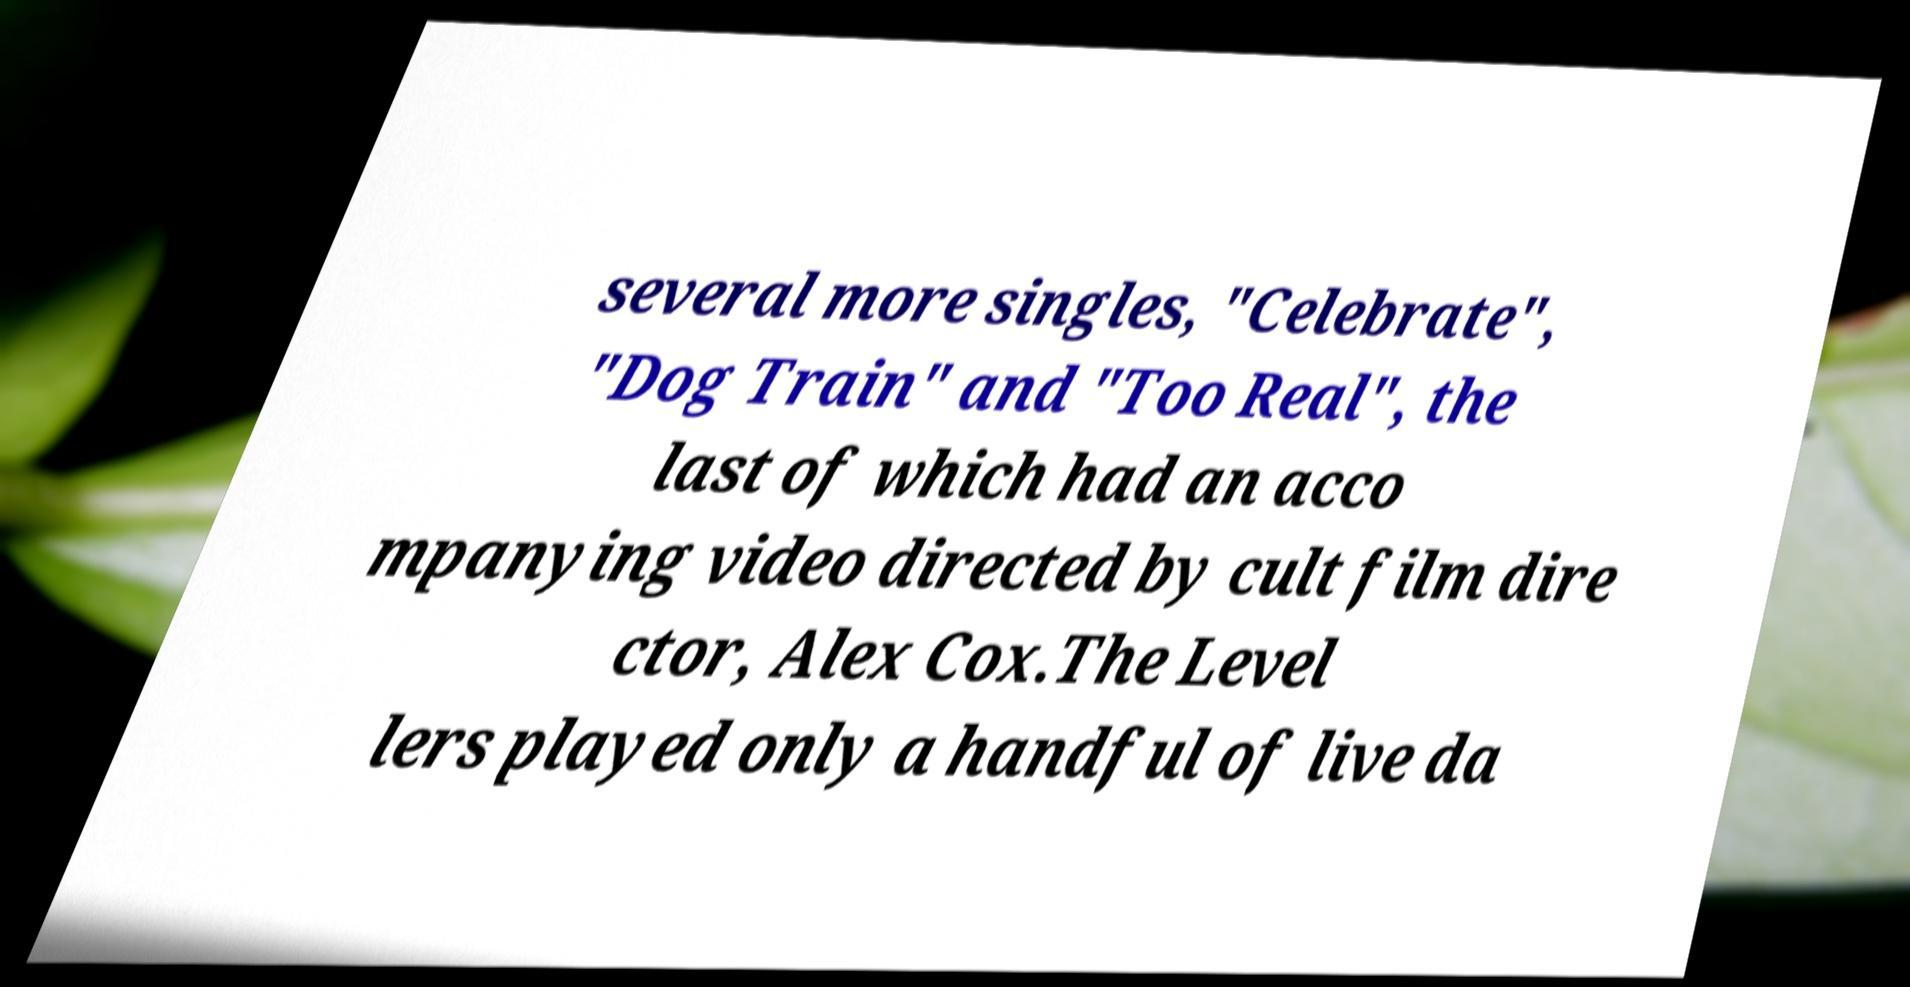Please read and relay the text visible in this image. What does it say? several more singles, "Celebrate", "Dog Train" and "Too Real", the last of which had an acco mpanying video directed by cult film dire ctor, Alex Cox.The Level lers played only a handful of live da 